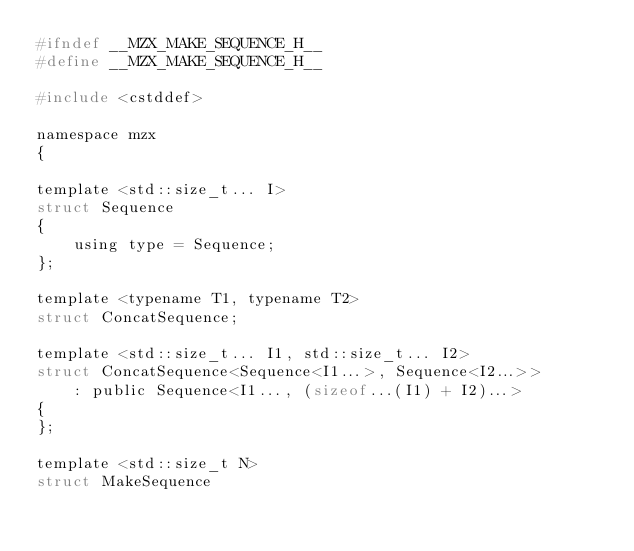Convert code to text. <code><loc_0><loc_0><loc_500><loc_500><_C_>#ifndef __MZX_MAKE_SEQUENCE_H__
#define __MZX_MAKE_SEQUENCE_H__

#include <cstddef>

namespace mzx
{

template <std::size_t... I>
struct Sequence
{
    using type = Sequence;
};

template <typename T1, typename T2>
struct ConcatSequence;

template <std::size_t... I1, std::size_t... I2>
struct ConcatSequence<Sequence<I1...>, Sequence<I2...>>
    : public Sequence<I1..., (sizeof...(I1) + I2)...>
{
};

template <std::size_t N>
struct MakeSequence</code> 